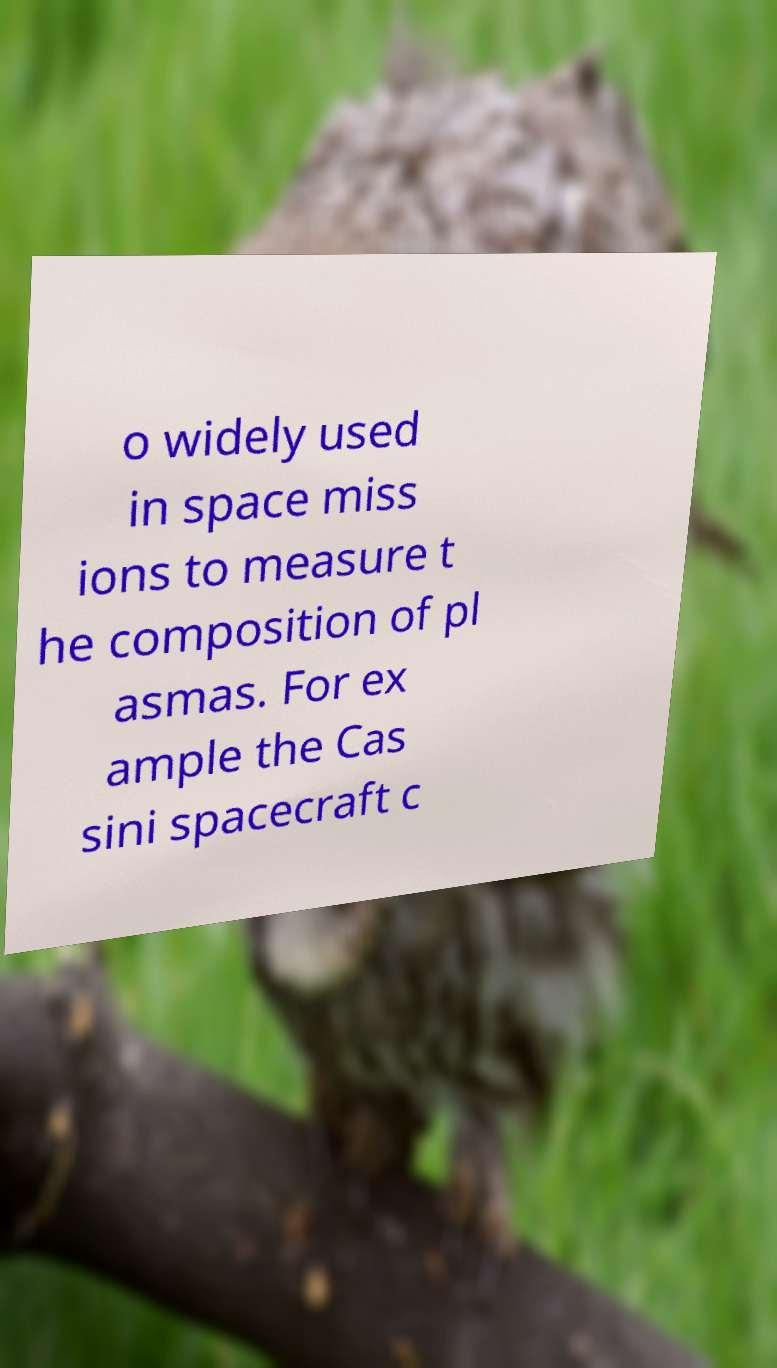Could you assist in decoding the text presented in this image and type it out clearly? o widely used in space miss ions to measure t he composition of pl asmas. For ex ample the Cas sini spacecraft c 